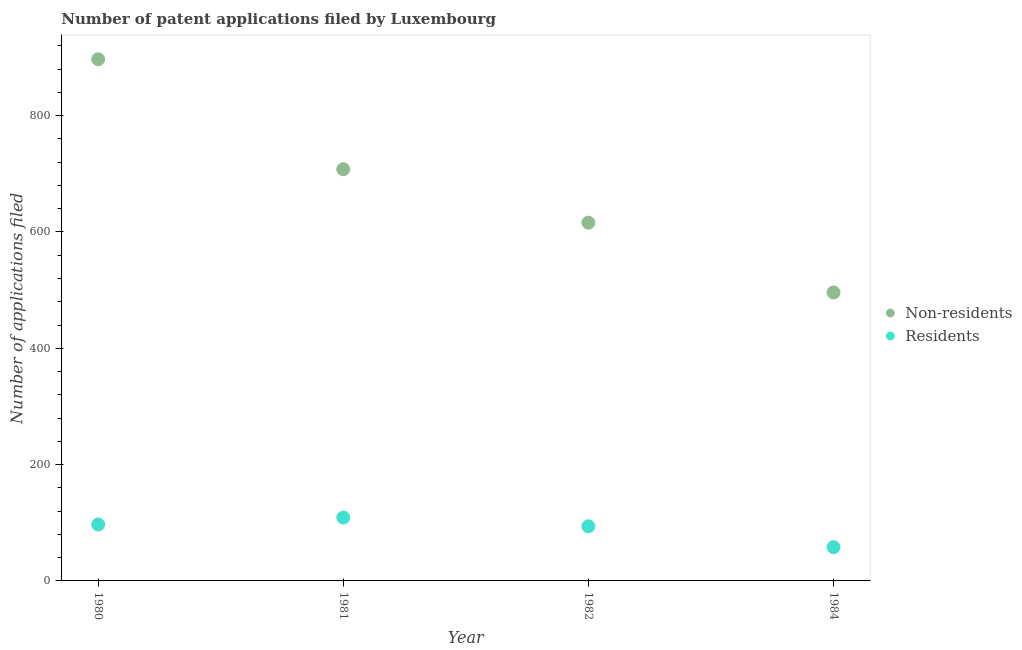What is the number of patent applications by non residents in 1982?
Give a very brief answer. 616. Across all years, what is the maximum number of patent applications by non residents?
Offer a very short reply. 897. Across all years, what is the minimum number of patent applications by non residents?
Offer a very short reply. 496. In which year was the number of patent applications by non residents minimum?
Make the answer very short. 1984. What is the total number of patent applications by non residents in the graph?
Offer a terse response. 2717. What is the difference between the number of patent applications by non residents in 1980 and that in 1981?
Give a very brief answer. 189. What is the difference between the number of patent applications by non residents in 1980 and the number of patent applications by residents in 1984?
Ensure brevity in your answer.  839. What is the average number of patent applications by residents per year?
Offer a very short reply. 89.5. In the year 1980, what is the difference between the number of patent applications by non residents and number of patent applications by residents?
Offer a terse response. 800. In how many years, is the number of patent applications by residents greater than 120?
Provide a short and direct response. 0. What is the ratio of the number of patent applications by non residents in 1980 to that in 1981?
Provide a succinct answer. 1.27. Is the number of patent applications by residents in 1981 less than that in 1984?
Your response must be concise. No. What is the difference between the highest and the second highest number of patent applications by non residents?
Offer a terse response. 189. What is the difference between the highest and the lowest number of patent applications by residents?
Offer a terse response. 51. In how many years, is the number of patent applications by non residents greater than the average number of patent applications by non residents taken over all years?
Give a very brief answer. 2. Is the sum of the number of patent applications by non residents in 1980 and 1984 greater than the maximum number of patent applications by residents across all years?
Ensure brevity in your answer.  Yes. How many dotlines are there?
Offer a terse response. 2. What is the difference between two consecutive major ticks on the Y-axis?
Provide a succinct answer. 200. Does the graph contain grids?
Your answer should be very brief. No. Where does the legend appear in the graph?
Offer a terse response. Center right. What is the title of the graph?
Your answer should be compact. Number of patent applications filed by Luxembourg. Does "Pregnant women" appear as one of the legend labels in the graph?
Offer a terse response. No. What is the label or title of the X-axis?
Your response must be concise. Year. What is the label or title of the Y-axis?
Ensure brevity in your answer.  Number of applications filed. What is the Number of applications filed in Non-residents in 1980?
Ensure brevity in your answer.  897. What is the Number of applications filed of Residents in 1980?
Keep it short and to the point. 97. What is the Number of applications filed in Non-residents in 1981?
Provide a succinct answer. 708. What is the Number of applications filed in Residents in 1981?
Your answer should be compact. 109. What is the Number of applications filed of Non-residents in 1982?
Provide a short and direct response. 616. What is the Number of applications filed of Residents in 1982?
Your answer should be compact. 94. What is the Number of applications filed in Non-residents in 1984?
Provide a succinct answer. 496. Across all years, what is the maximum Number of applications filed in Non-residents?
Your answer should be compact. 897. Across all years, what is the maximum Number of applications filed of Residents?
Offer a very short reply. 109. Across all years, what is the minimum Number of applications filed of Non-residents?
Offer a very short reply. 496. Across all years, what is the minimum Number of applications filed in Residents?
Provide a succinct answer. 58. What is the total Number of applications filed in Non-residents in the graph?
Your response must be concise. 2717. What is the total Number of applications filed of Residents in the graph?
Provide a succinct answer. 358. What is the difference between the Number of applications filed of Non-residents in 1980 and that in 1981?
Make the answer very short. 189. What is the difference between the Number of applications filed of Residents in 1980 and that in 1981?
Provide a short and direct response. -12. What is the difference between the Number of applications filed of Non-residents in 1980 and that in 1982?
Give a very brief answer. 281. What is the difference between the Number of applications filed in Non-residents in 1980 and that in 1984?
Ensure brevity in your answer.  401. What is the difference between the Number of applications filed of Residents in 1980 and that in 1984?
Your answer should be compact. 39. What is the difference between the Number of applications filed of Non-residents in 1981 and that in 1982?
Provide a succinct answer. 92. What is the difference between the Number of applications filed of Residents in 1981 and that in 1982?
Offer a very short reply. 15. What is the difference between the Number of applications filed of Non-residents in 1981 and that in 1984?
Your answer should be compact. 212. What is the difference between the Number of applications filed of Non-residents in 1982 and that in 1984?
Offer a very short reply. 120. What is the difference between the Number of applications filed of Residents in 1982 and that in 1984?
Make the answer very short. 36. What is the difference between the Number of applications filed of Non-residents in 1980 and the Number of applications filed of Residents in 1981?
Provide a succinct answer. 788. What is the difference between the Number of applications filed of Non-residents in 1980 and the Number of applications filed of Residents in 1982?
Your answer should be compact. 803. What is the difference between the Number of applications filed of Non-residents in 1980 and the Number of applications filed of Residents in 1984?
Make the answer very short. 839. What is the difference between the Number of applications filed in Non-residents in 1981 and the Number of applications filed in Residents in 1982?
Your answer should be very brief. 614. What is the difference between the Number of applications filed of Non-residents in 1981 and the Number of applications filed of Residents in 1984?
Your response must be concise. 650. What is the difference between the Number of applications filed in Non-residents in 1982 and the Number of applications filed in Residents in 1984?
Provide a succinct answer. 558. What is the average Number of applications filed of Non-residents per year?
Give a very brief answer. 679.25. What is the average Number of applications filed in Residents per year?
Your response must be concise. 89.5. In the year 1980, what is the difference between the Number of applications filed of Non-residents and Number of applications filed of Residents?
Make the answer very short. 800. In the year 1981, what is the difference between the Number of applications filed of Non-residents and Number of applications filed of Residents?
Provide a short and direct response. 599. In the year 1982, what is the difference between the Number of applications filed in Non-residents and Number of applications filed in Residents?
Your response must be concise. 522. In the year 1984, what is the difference between the Number of applications filed of Non-residents and Number of applications filed of Residents?
Provide a succinct answer. 438. What is the ratio of the Number of applications filed of Non-residents in 1980 to that in 1981?
Your answer should be compact. 1.27. What is the ratio of the Number of applications filed of Residents in 1980 to that in 1981?
Give a very brief answer. 0.89. What is the ratio of the Number of applications filed in Non-residents in 1980 to that in 1982?
Provide a short and direct response. 1.46. What is the ratio of the Number of applications filed in Residents in 1980 to that in 1982?
Provide a succinct answer. 1.03. What is the ratio of the Number of applications filed of Non-residents in 1980 to that in 1984?
Offer a very short reply. 1.81. What is the ratio of the Number of applications filed in Residents in 1980 to that in 1984?
Ensure brevity in your answer.  1.67. What is the ratio of the Number of applications filed in Non-residents in 1981 to that in 1982?
Provide a succinct answer. 1.15. What is the ratio of the Number of applications filed in Residents in 1981 to that in 1982?
Offer a terse response. 1.16. What is the ratio of the Number of applications filed of Non-residents in 1981 to that in 1984?
Provide a succinct answer. 1.43. What is the ratio of the Number of applications filed of Residents in 1981 to that in 1984?
Your answer should be very brief. 1.88. What is the ratio of the Number of applications filed in Non-residents in 1982 to that in 1984?
Provide a succinct answer. 1.24. What is the ratio of the Number of applications filed in Residents in 1982 to that in 1984?
Provide a succinct answer. 1.62. What is the difference between the highest and the second highest Number of applications filed of Non-residents?
Keep it short and to the point. 189. What is the difference between the highest and the second highest Number of applications filed in Residents?
Provide a succinct answer. 12. What is the difference between the highest and the lowest Number of applications filed in Non-residents?
Offer a terse response. 401. 